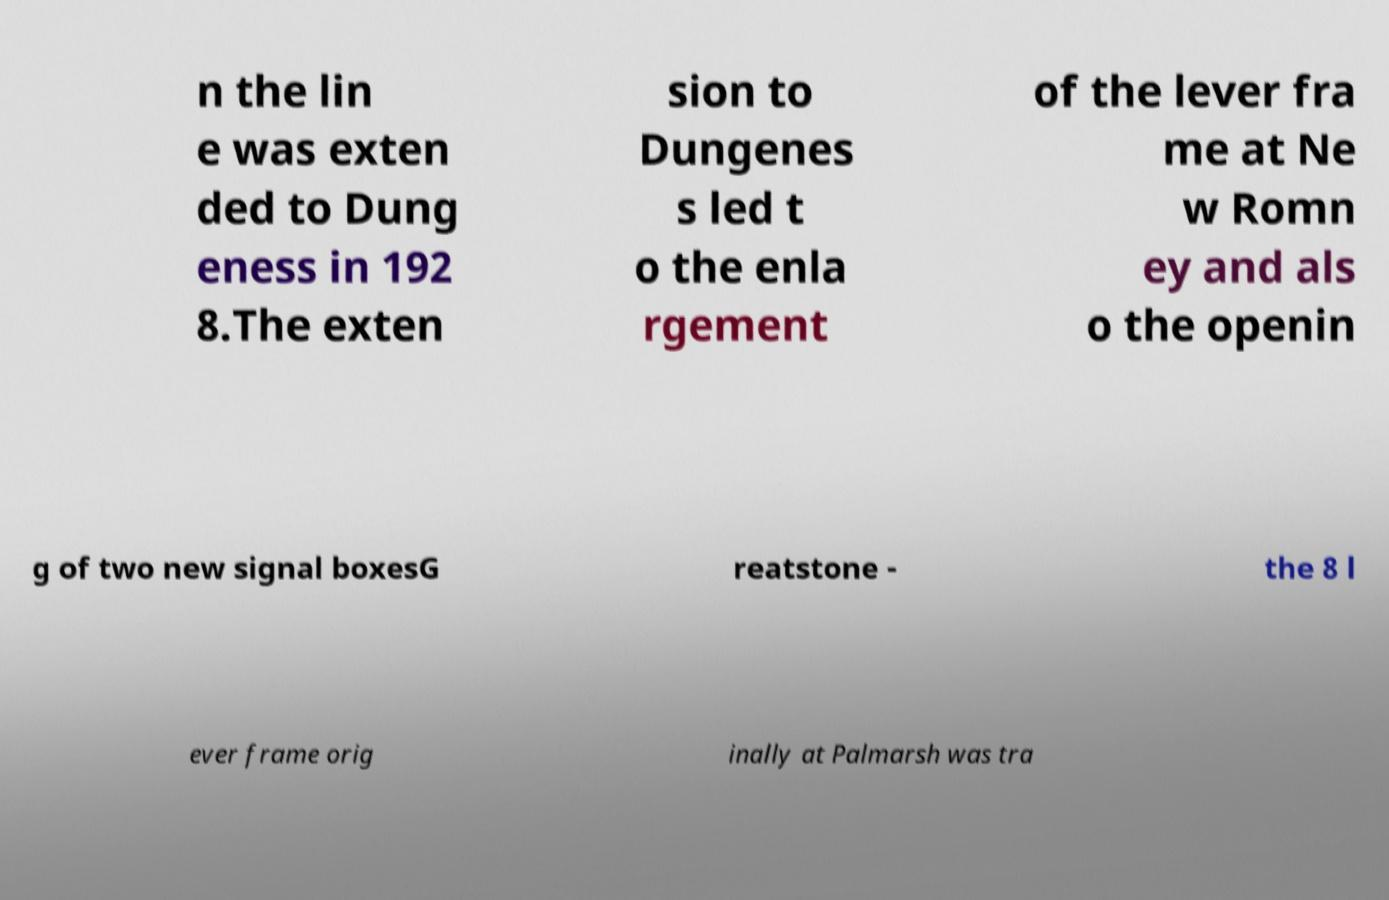Could you assist in decoding the text presented in this image and type it out clearly? n the lin e was exten ded to Dung eness in 192 8.The exten sion to Dungenes s led t o the enla rgement of the lever fra me at Ne w Romn ey and als o the openin g of two new signal boxesG reatstone - the 8 l ever frame orig inally at Palmarsh was tra 